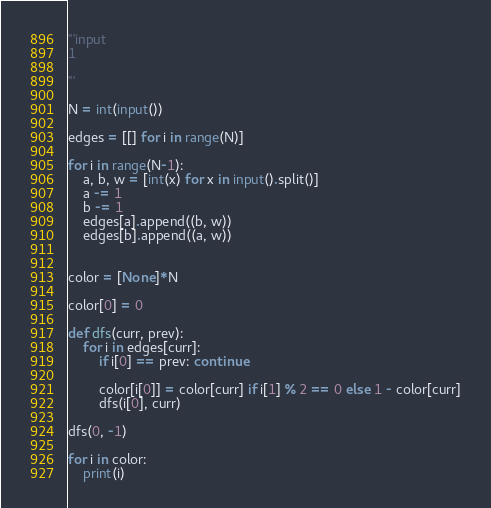<code> <loc_0><loc_0><loc_500><loc_500><_Python_>'''input
1

'''

N = int(input())

edges = [[] for i in range(N)]

for i in range(N-1):
	a, b, w = [int(x) for x in input().split()]
	a -= 1
	b -= 1
	edges[a].append((b, w))
	edges[b].append((a, w))


color = [None]*N

color[0] = 0

def dfs(curr, prev):
	for i in edges[curr]:
		if i[0] == prev: continue

		color[i[0]] = color[curr] if i[1] % 2 == 0 else 1 - color[curr]
		dfs(i[0], curr)

dfs(0, -1)

for i in color:
	print(i)</code> 